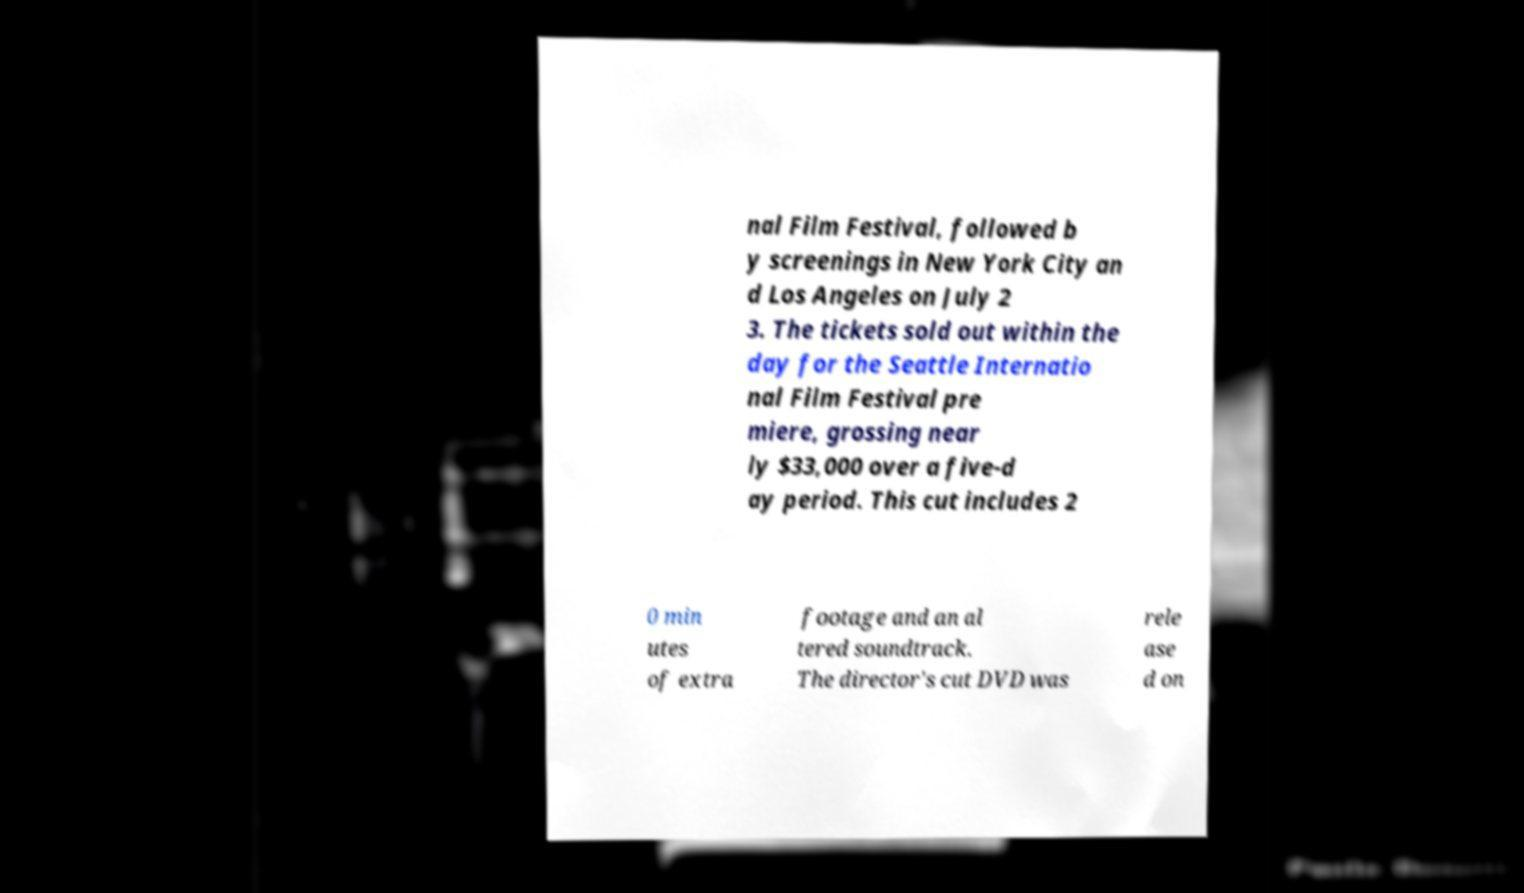Can you accurately transcribe the text from the provided image for me? nal Film Festival, followed b y screenings in New York City an d Los Angeles on July 2 3. The tickets sold out within the day for the Seattle Internatio nal Film Festival pre miere, grossing near ly $33,000 over a five-d ay period. This cut includes 2 0 min utes of extra footage and an al tered soundtrack. The director's cut DVD was rele ase d on 